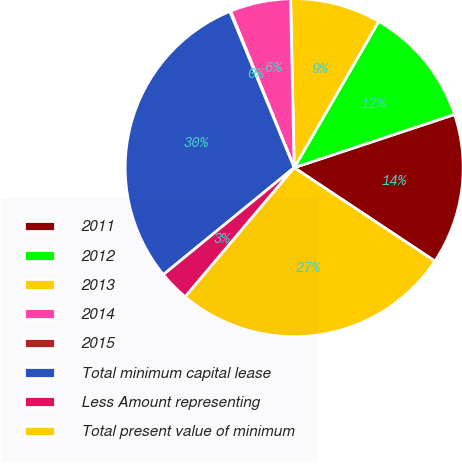Convert chart to OTSL. <chart><loc_0><loc_0><loc_500><loc_500><pie_chart><fcel>2011<fcel>2012<fcel>2013<fcel>2014<fcel>2015<fcel>Total minimum capital lease<fcel>Less Amount representing<fcel>Total present value of minimum<nl><fcel>14.43%<fcel>11.56%<fcel>8.68%<fcel>5.81%<fcel>0.07%<fcel>29.69%<fcel>2.94%<fcel>26.82%<nl></chart> 